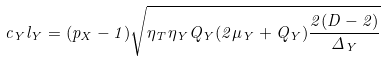Convert formula to latex. <formula><loc_0><loc_0><loc_500><loc_500>c _ { Y } l _ { Y } = ( p _ { X } - 1 ) \sqrt { \eta _ { T } \eta _ { Y } Q _ { Y } ( 2 \mu _ { Y } + Q _ { Y } ) \frac { 2 ( D - 2 ) } { \Delta _ { Y } } }</formula> 